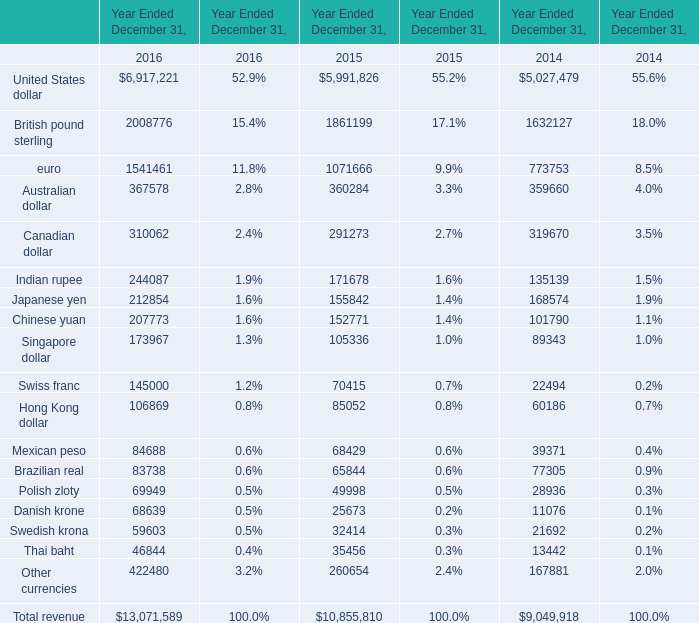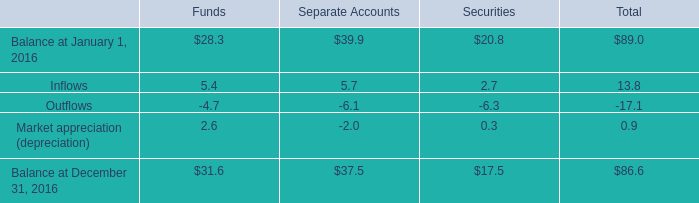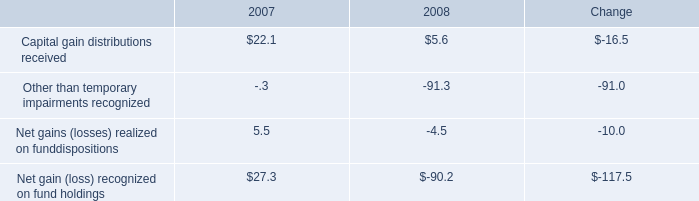what was the total occupancy and facility costs together with depreciation expense in 2007 , in millions of dollars? 
Computations: (18 / 12%)
Answer: 150.0. 